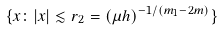<formula> <loc_0><loc_0><loc_500><loc_500>\{ x \colon | x | \lesssim r _ { 2 } = ( \mu h ) ^ { - 1 / ( m _ { 1 } - 2 m ) } \}</formula> 